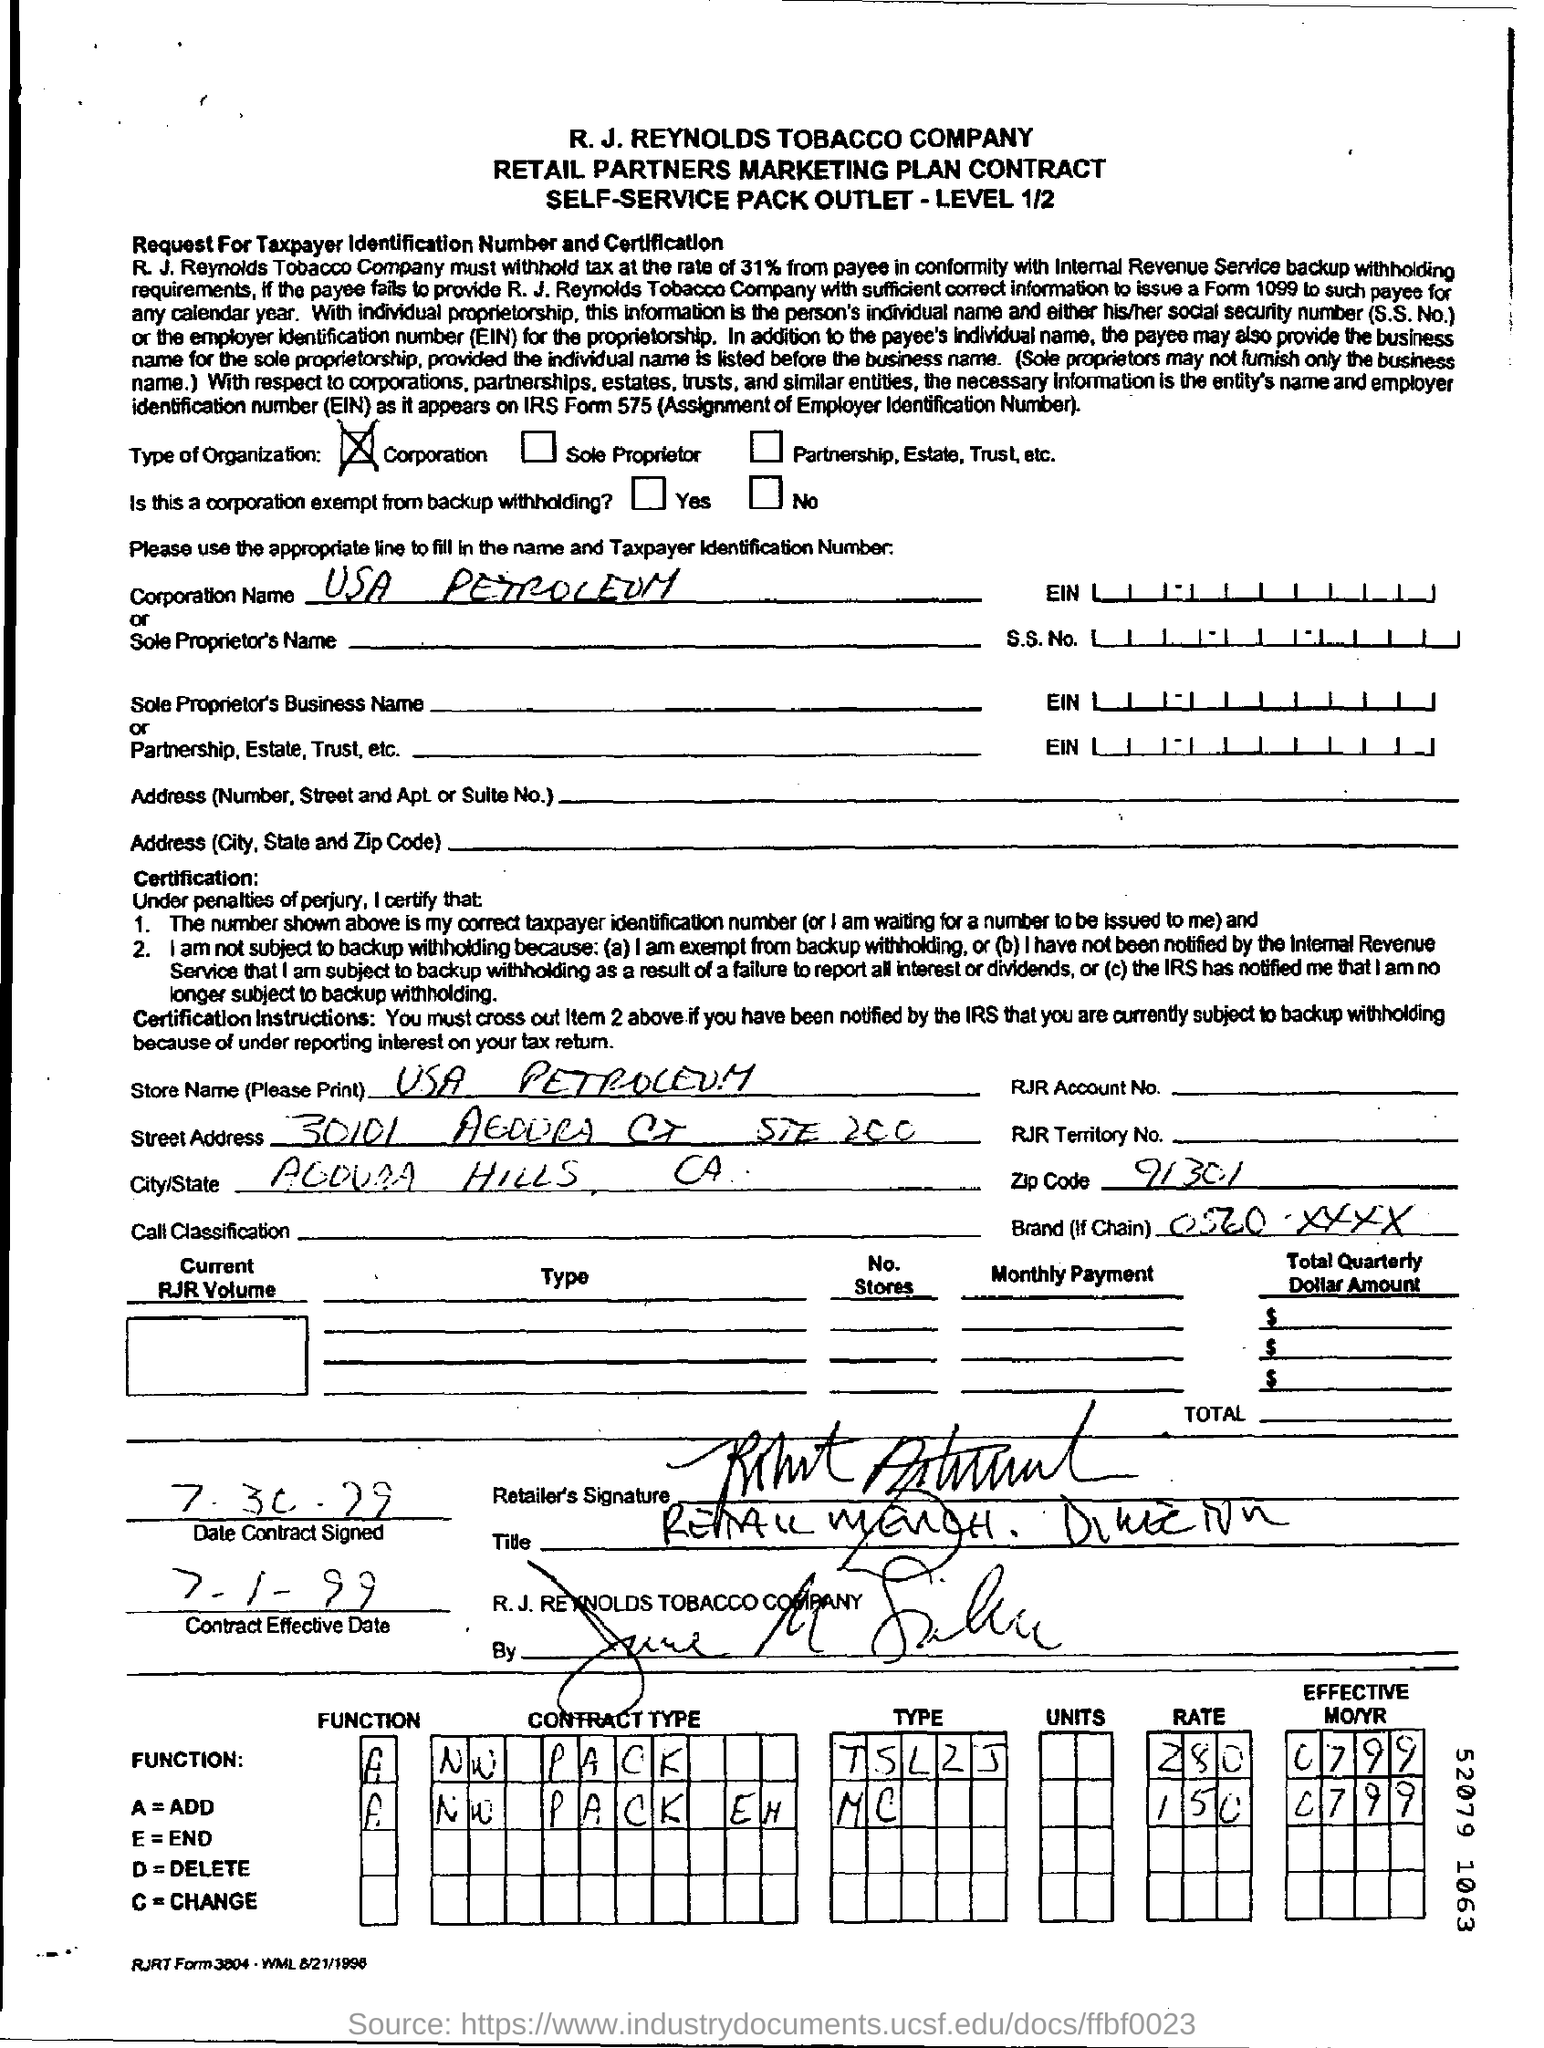When is the contract effective date?
Provide a succinct answer. 7 - 1 - 99. What is the type of organization?
Keep it short and to the point. Corporation. What is the corporation name?
Provide a succinct answer. USA PETROLEUM. 